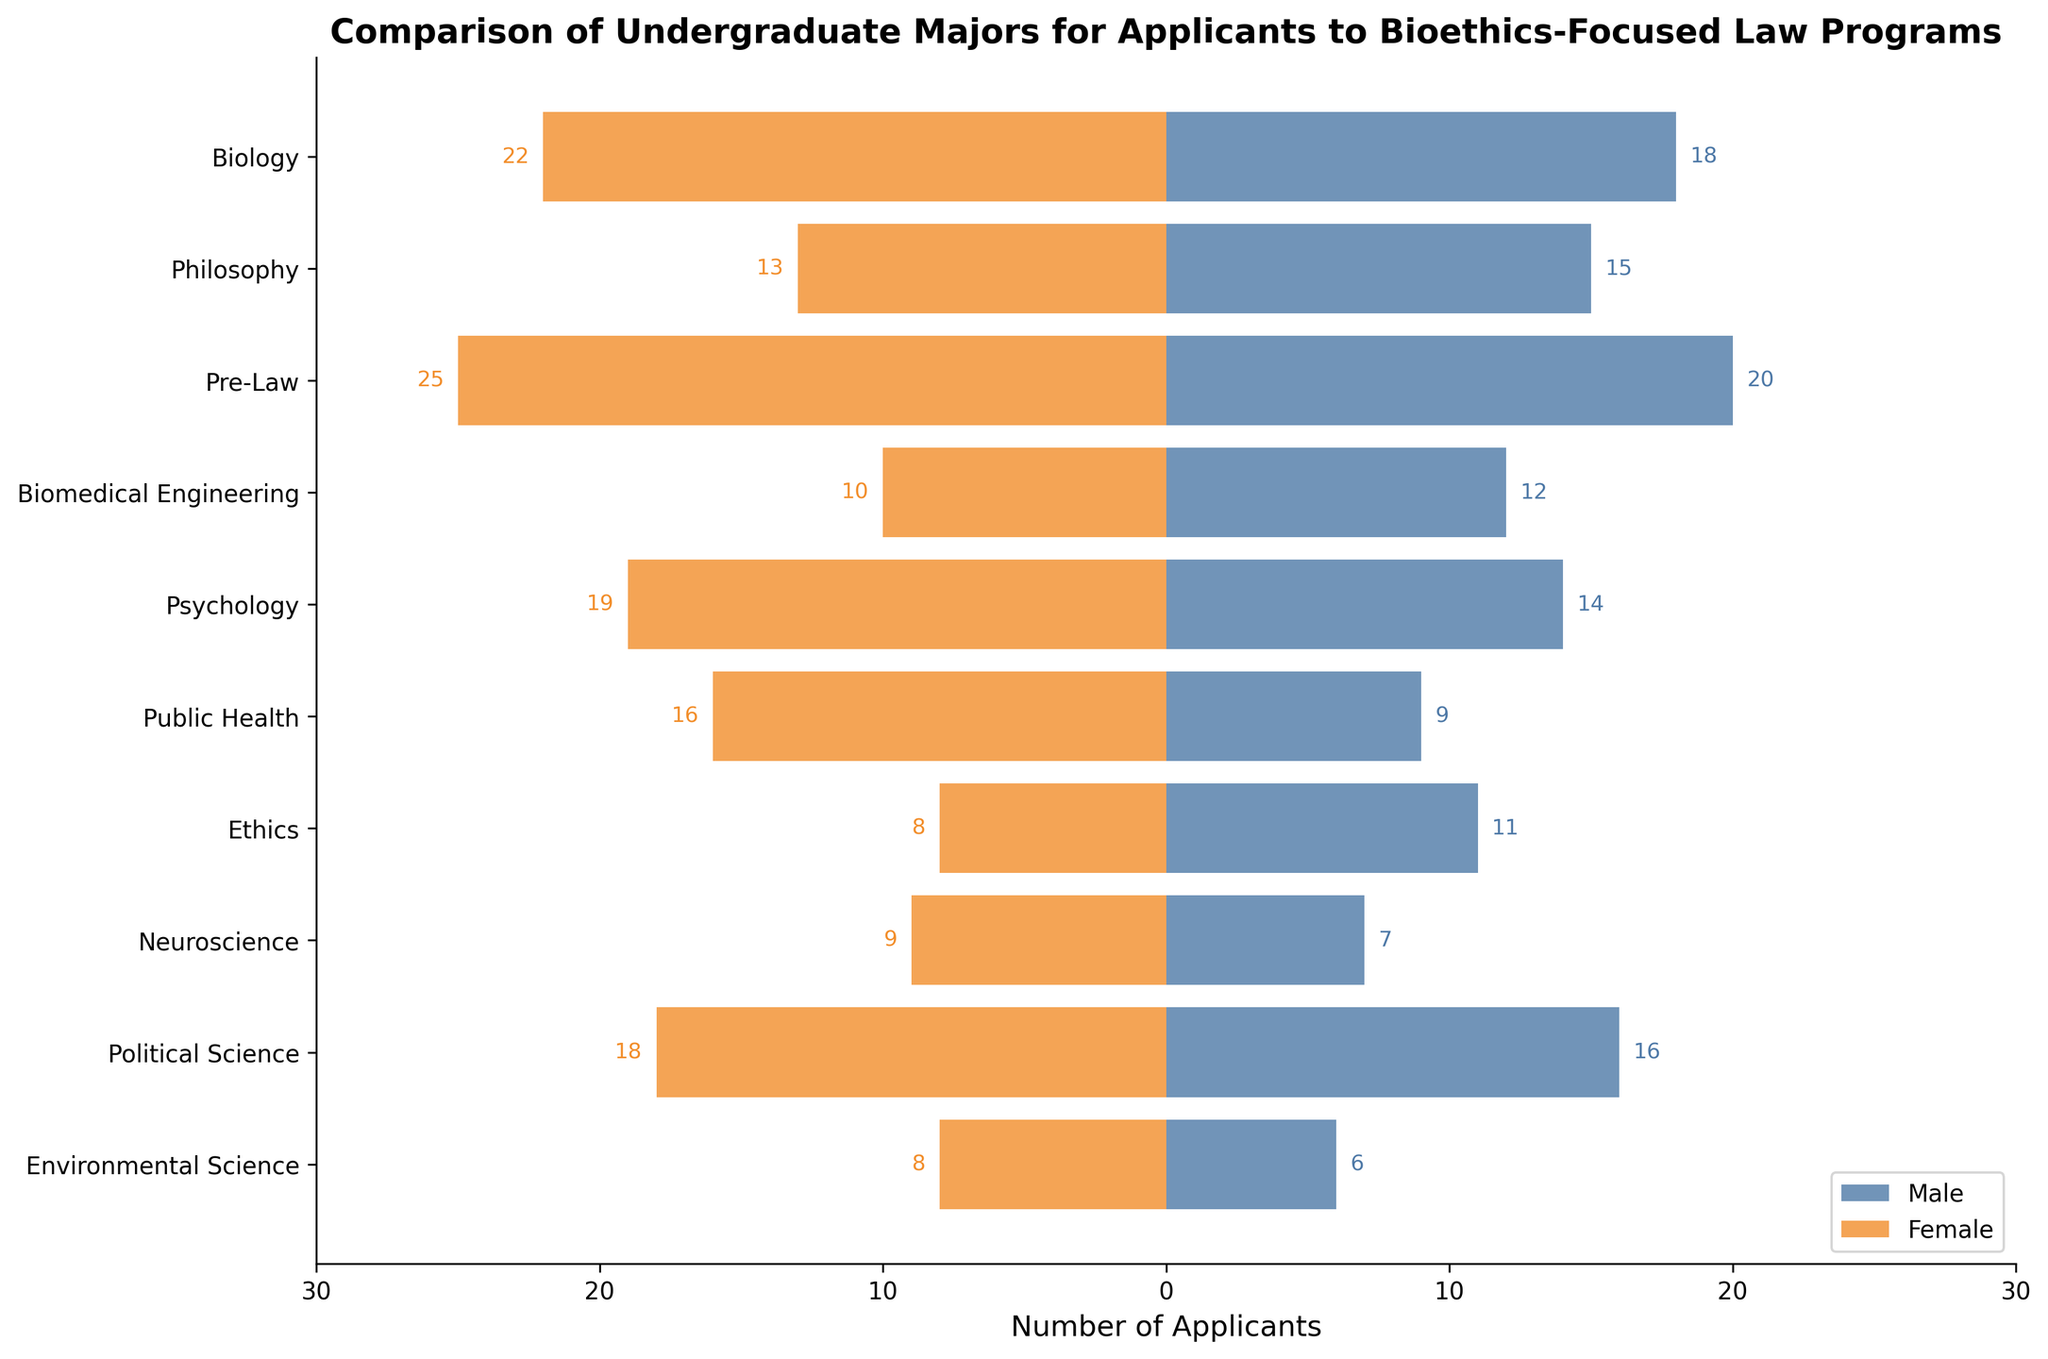What is the title of the figure? The title is written at the top of the chart and provides the main topic of the visualization.
Answer: "Comparison of Undergraduate Majors for Applicants to Bioethics-Focused Law Programs" What do the colors blue and orange represent in the chart? The colors represent different groups in the population: blue represents male applicants and orange represents female applicants.
Answer: Male and Female Which undergraduate major has the highest number of female applicants? By comparing the lengths of the orange bars, we can see that the highest number of female applicants is for Pre-Law.
Answer: Pre-Law How many majors have more male applicants than female applicants? By comparing the lengths of the blue and orange bars for each major, we see that the following majors have more male applicants than female: Biology, Philosophy, Biomedical Engineering, Ethics, Political Science, and Environmental Science, making a total of six.
Answer: Six What is the total number of male applicants for Philosophy and Psychology combined? Sum the number of male applicants for Philosophy (15) and Psychology (14). 15 + 14 = 29.
Answer: 29 Which major has the smallest difference between the number of male and female applicants? Calculate the absolute difference for each major: Biology (4), Philosophy (2), Pre-Law (5), Biomedical Engineering (2), Psychology (5), Public Health (7), Ethics (3), Neuroscience (2), Political Science (2), Environmental Science (2). The smallest differences are all 2, so multiple majors qualify: Philosophy, Biomedical Engineering, Neuroscience, Political Science, and Environmental Science.
Answer: Multiple majors (Philosophy, Biomedical Engineering, Neuroscience, Political Science, Environmental Science) In which category are male applicants nearly double the female applicants? Look for a major where the male bar is roughly double the length of the female bar. In Ethics, there are 11 male and 8 female, which is not quite double. None of the categories meet this criterion exactly.
Answer: None Which major has almost an equal number of male and female applicants? Look for bars of nearly equal length. Political Science has 16 male and 18 female, and Neuroscience has 7 male and 9 female. Philosophy also has nearly equal numbers: 15 male and 13 female.
Answer: Philosophy, Neuroscience, Political Science What is the combined total number of applicants for Public Health? Sum the male (9) and female (16) applicants for Public Health. 9 + 16 = 25.
Answer: 25 Which major has the highest total number of applicants? By summing the values for each major, we can see Pre-Law has the highest total: Male (20) + Female (25) = 45.
Answer: Pre-Law 